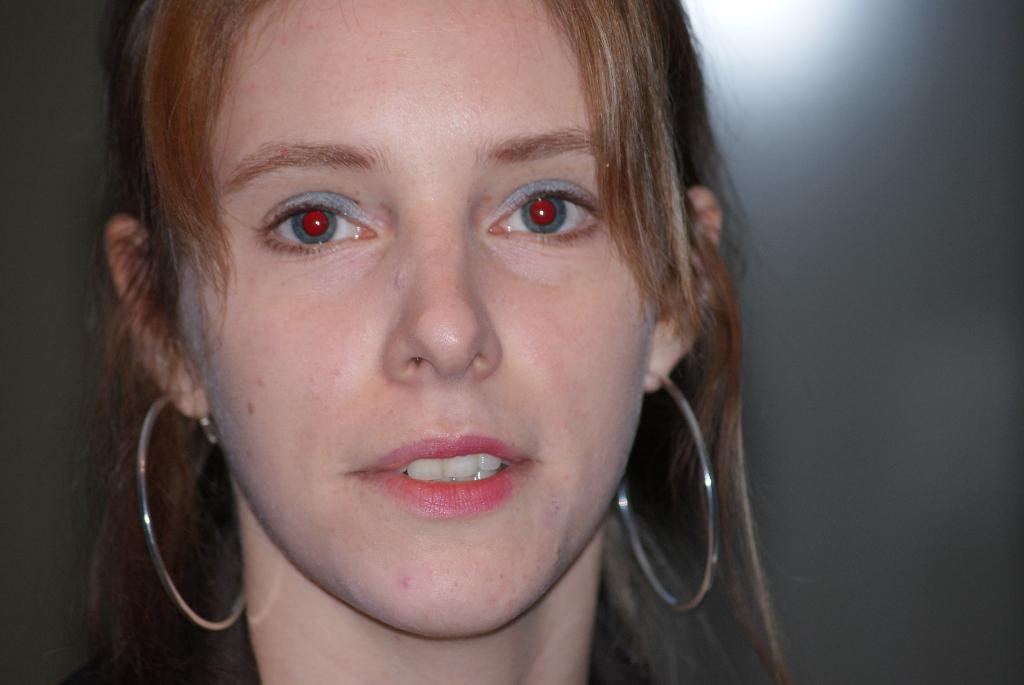Who is present in the image? There is a woman in the image. What accessories is the woman wearing? The woman is wearing earrings. What is unusual about the woman's eyes in the image? The woman's eyes have red pupils. How does the woman react to the earthquake in the image? There is no earthquake present in the image, so the woman's reaction cannot be determined. 